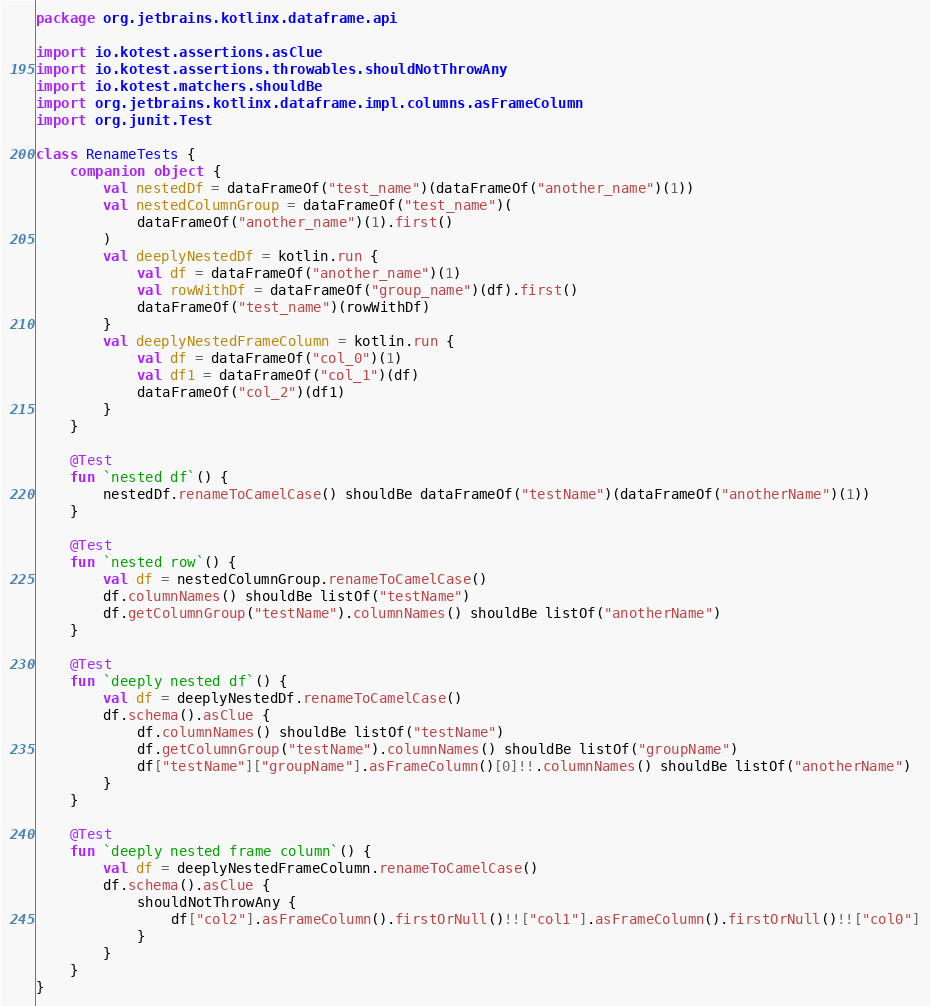Convert code to text. <code><loc_0><loc_0><loc_500><loc_500><_Kotlin_>package org.jetbrains.kotlinx.dataframe.api

import io.kotest.assertions.asClue
import io.kotest.assertions.throwables.shouldNotThrowAny
import io.kotest.matchers.shouldBe
import org.jetbrains.kotlinx.dataframe.impl.columns.asFrameColumn
import org.junit.Test

class RenameTests {
    companion object {
        val nestedDf = dataFrameOf("test_name")(dataFrameOf("another_name")(1))
        val nestedColumnGroup = dataFrameOf("test_name")(
            dataFrameOf("another_name")(1).first()
        )
        val deeplyNestedDf = kotlin.run {
            val df = dataFrameOf("another_name")(1)
            val rowWithDf = dataFrameOf("group_name")(df).first()
            dataFrameOf("test_name")(rowWithDf)
        }
        val deeplyNestedFrameColumn = kotlin.run {
            val df = dataFrameOf("col_0")(1)
            val df1 = dataFrameOf("col_1")(df)
            dataFrameOf("col_2")(df1)
        }
    }

    @Test
    fun `nested df`() {
        nestedDf.renameToCamelCase() shouldBe dataFrameOf("testName")(dataFrameOf("anotherName")(1))
    }

    @Test
    fun `nested row`() {
        val df = nestedColumnGroup.renameToCamelCase()
        df.columnNames() shouldBe listOf("testName")
        df.getColumnGroup("testName").columnNames() shouldBe listOf("anotherName")
    }

    @Test
    fun `deeply nested df`() {
        val df = deeplyNestedDf.renameToCamelCase()
        df.schema().asClue {
            df.columnNames() shouldBe listOf("testName")
            df.getColumnGroup("testName").columnNames() shouldBe listOf("groupName")
            df["testName"]["groupName"].asFrameColumn()[0]!!.columnNames() shouldBe listOf("anotherName")
        }
    }

    @Test
    fun `deeply nested frame column`() {
        val df = deeplyNestedFrameColumn.renameToCamelCase()
        df.schema().asClue {
            shouldNotThrowAny {
                df["col2"].asFrameColumn().firstOrNull()!!["col1"].asFrameColumn().firstOrNull()!!["col0"]
            }
        }
    }
}
</code> 